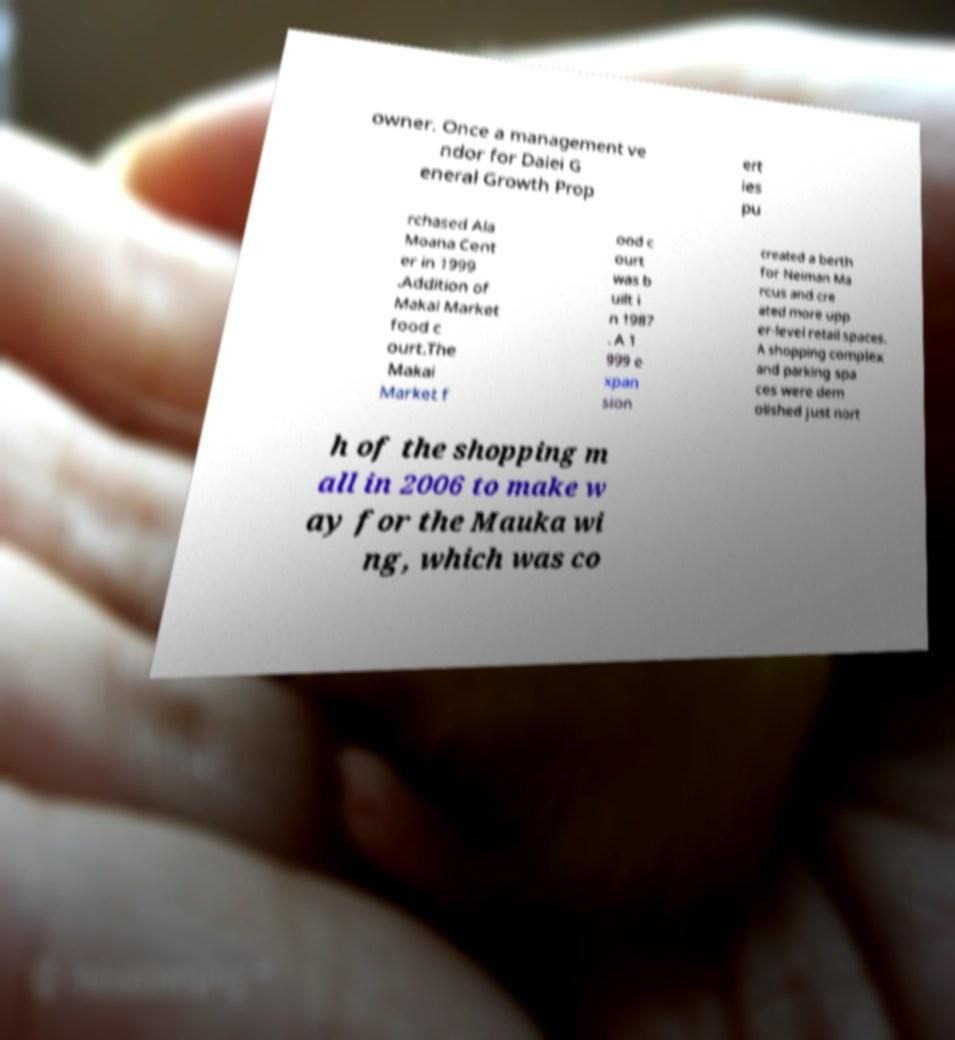Can you read and provide the text displayed in the image?This photo seems to have some interesting text. Can you extract and type it out for me? owner. Once a management ve ndor for Daiei G eneral Growth Prop ert ies pu rchased Ala Moana Cent er in 1999 .Addition of Makai Market food c ourt.The Makai Market f ood c ourt was b uilt i n 1987 . A 1 999 e xpan sion created a berth for Neiman Ma rcus and cre ated more upp er-level retail spaces. A shopping complex and parking spa ces were dem olished just nort h of the shopping m all in 2006 to make w ay for the Mauka wi ng, which was co 